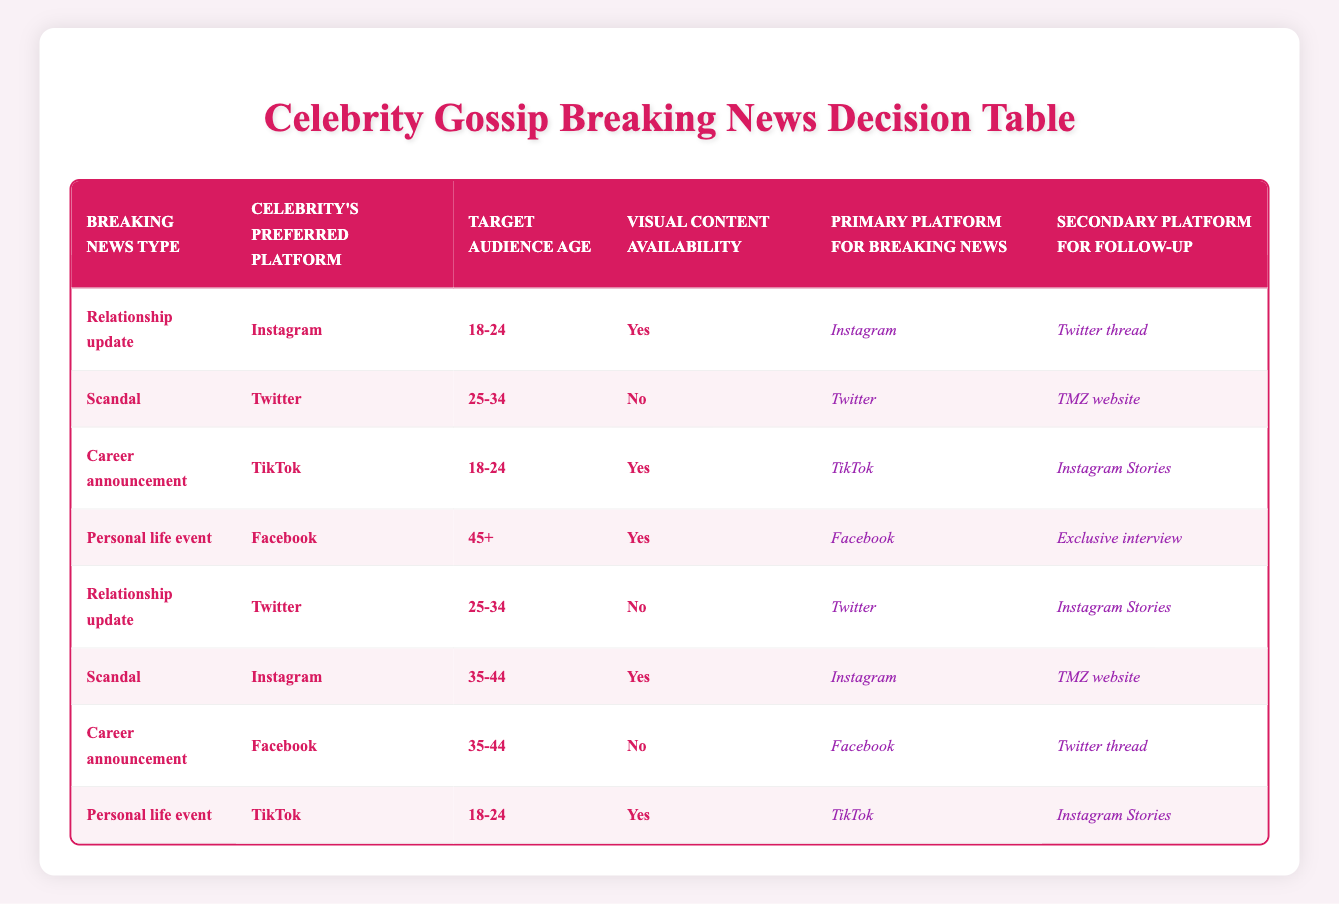What is the primary platform for breaking news about a scandal involving a celebrity on Twitter? From the table, we find the row for "Scandal" where "Celebrity's preferred platform" is "Twitter." The corresponding primary platform for breaking news is listed as "Twitter."
Answer: Twitter For an 18-24 demographic, which primary platform is used for a relationship update when visual content is available? Referring to the table, we see that when the breaking news type is "Relationship update," the preferred platform is "Instagram," target audience is "18-24," and visual content is "Yes," the primary platform for breaking news is "Instagram."
Answer: Instagram What are the secondary platforms for breaking news on Facebook for personal life events and visual content is available? We look for the row where the "Personal life event" is combined with "Facebook" and "Yes" for visual content. In that row, the secondary platform for follow-up is "Exclusive interview."
Answer: Exclusive interview Is TikTok chosen as the primary platform for career announcements for the 35-44 age group? Checking the table, there is no entry for "Career announcement" using TikTok specifically for the "35-44" age group. Instead, TikTok is mentioned for the "18-24" age group. Therefore, the answer is 'no'.
Answer: No How many platforms are listed for following up a scandal if the celebrity prefers Instagram and the age group is 35-44? We look for instances of "Scandal" in the table with "Instagram" as the platform and target age "35-44." There is such a row in the table, and it shows "TMZ website" as the secondary platform, meaning there is one follow-up platform listed.
Answer: 1 